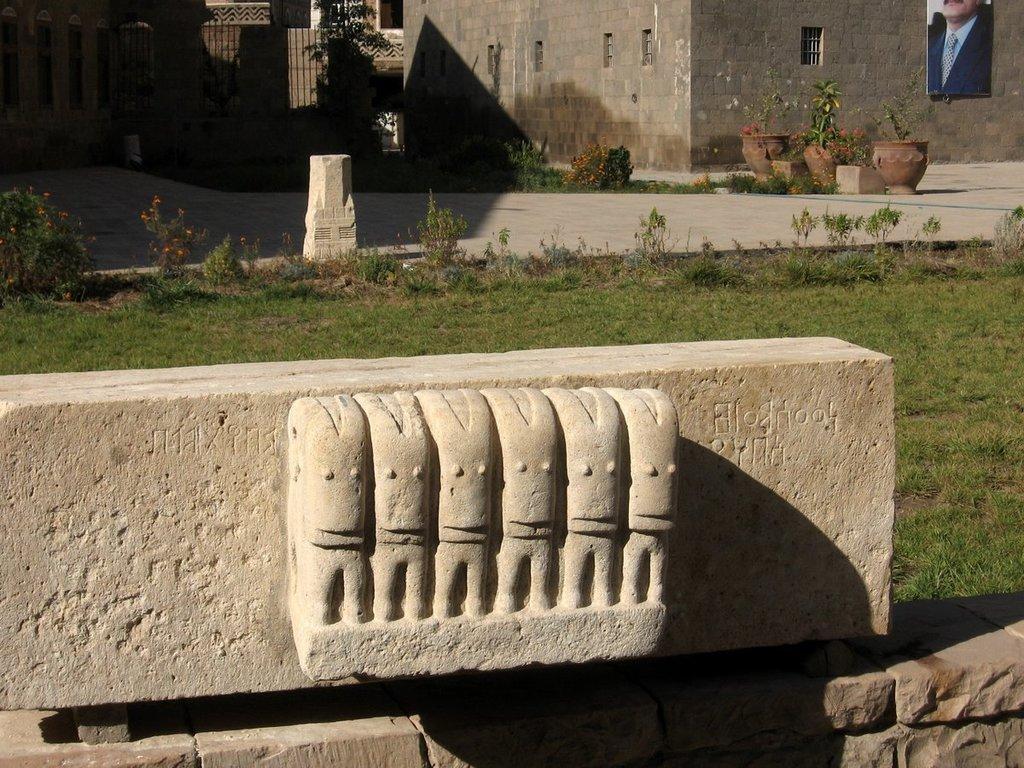Describe this image in one or two sentences. There is a cement structure present at the bottom of this image. We can see a grassy land in the middle of this image. There are plants and buildings present at the top of this image. There is a photo frame attached to the wall which is in the top right corner of this image. 